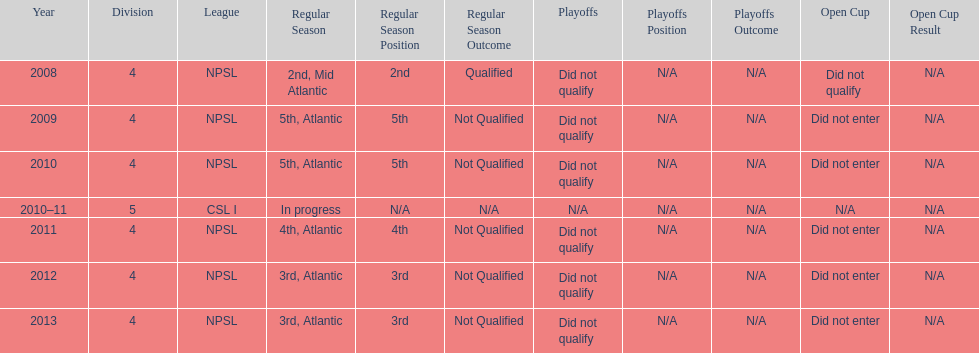Other than npsl, what league has ny mens soccer team played in? CSL I. 